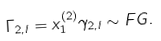<formula> <loc_0><loc_0><loc_500><loc_500>\Gamma _ { 2 , l } = x _ { 1 } ^ { ( 2 ) } \gamma _ { 2 , l } \sim F G .</formula> 